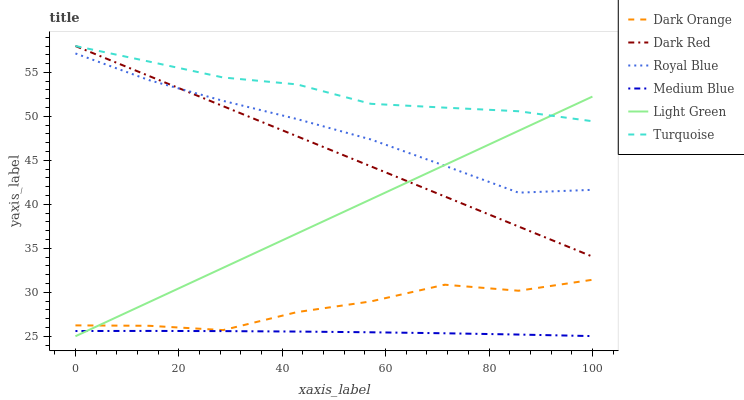Does Medium Blue have the minimum area under the curve?
Answer yes or no. Yes. Does Turquoise have the maximum area under the curve?
Answer yes or no. Yes. Does Dark Red have the minimum area under the curve?
Answer yes or no. No. Does Dark Red have the maximum area under the curve?
Answer yes or no. No. Is Light Green the smoothest?
Answer yes or no. Yes. Is Dark Orange the roughest?
Answer yes or no. Yes. Is Turquoise the smoothest?
Answer yes or no. No. Is Turquoise the roughest?
Answer yes or no. No. Does Light Green have the lowest value?
Answer yes or no. Yes. Does Dark Red have the lowest value?
Answer yes or no. No. Does Dark Red have the highest value?
Answer yes or no. Yes. Does Medium Blue have the highest value?
Answer yes or no. No. Is Royal Blue less than Turquoise?
Answer yes or no. Yes. Is Royal Blue greater than Medium Blue?
Answer yes or no. Yes. Does Royal Blue intersect Light Green?
Answer yes or no. Yes. Is Royal Blue less than Light Green?
Answer yes or no. No. Is Royal Blue greater than Light Green?
Answer yes or no. No. Does Royal Blue intersect Turquoise?
Answer yes or no. No. 